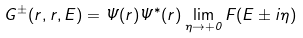Convert formula to latex. <formula><loc_0><loc_0><loc_500><loc_500>G ^ { \pm } ( { r } , { r } , E ) = \Psi ( { r } ) \Psi ^ { * } ( { r } ) \lim _ { \eta \rightarrow + 0 } F ( E \pm i \eta )</formula> 